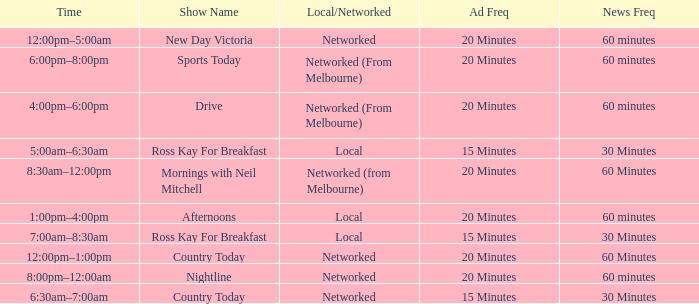What Time has a Show Name of mornings with neil mitchell? 8:30am–12:00pm. 